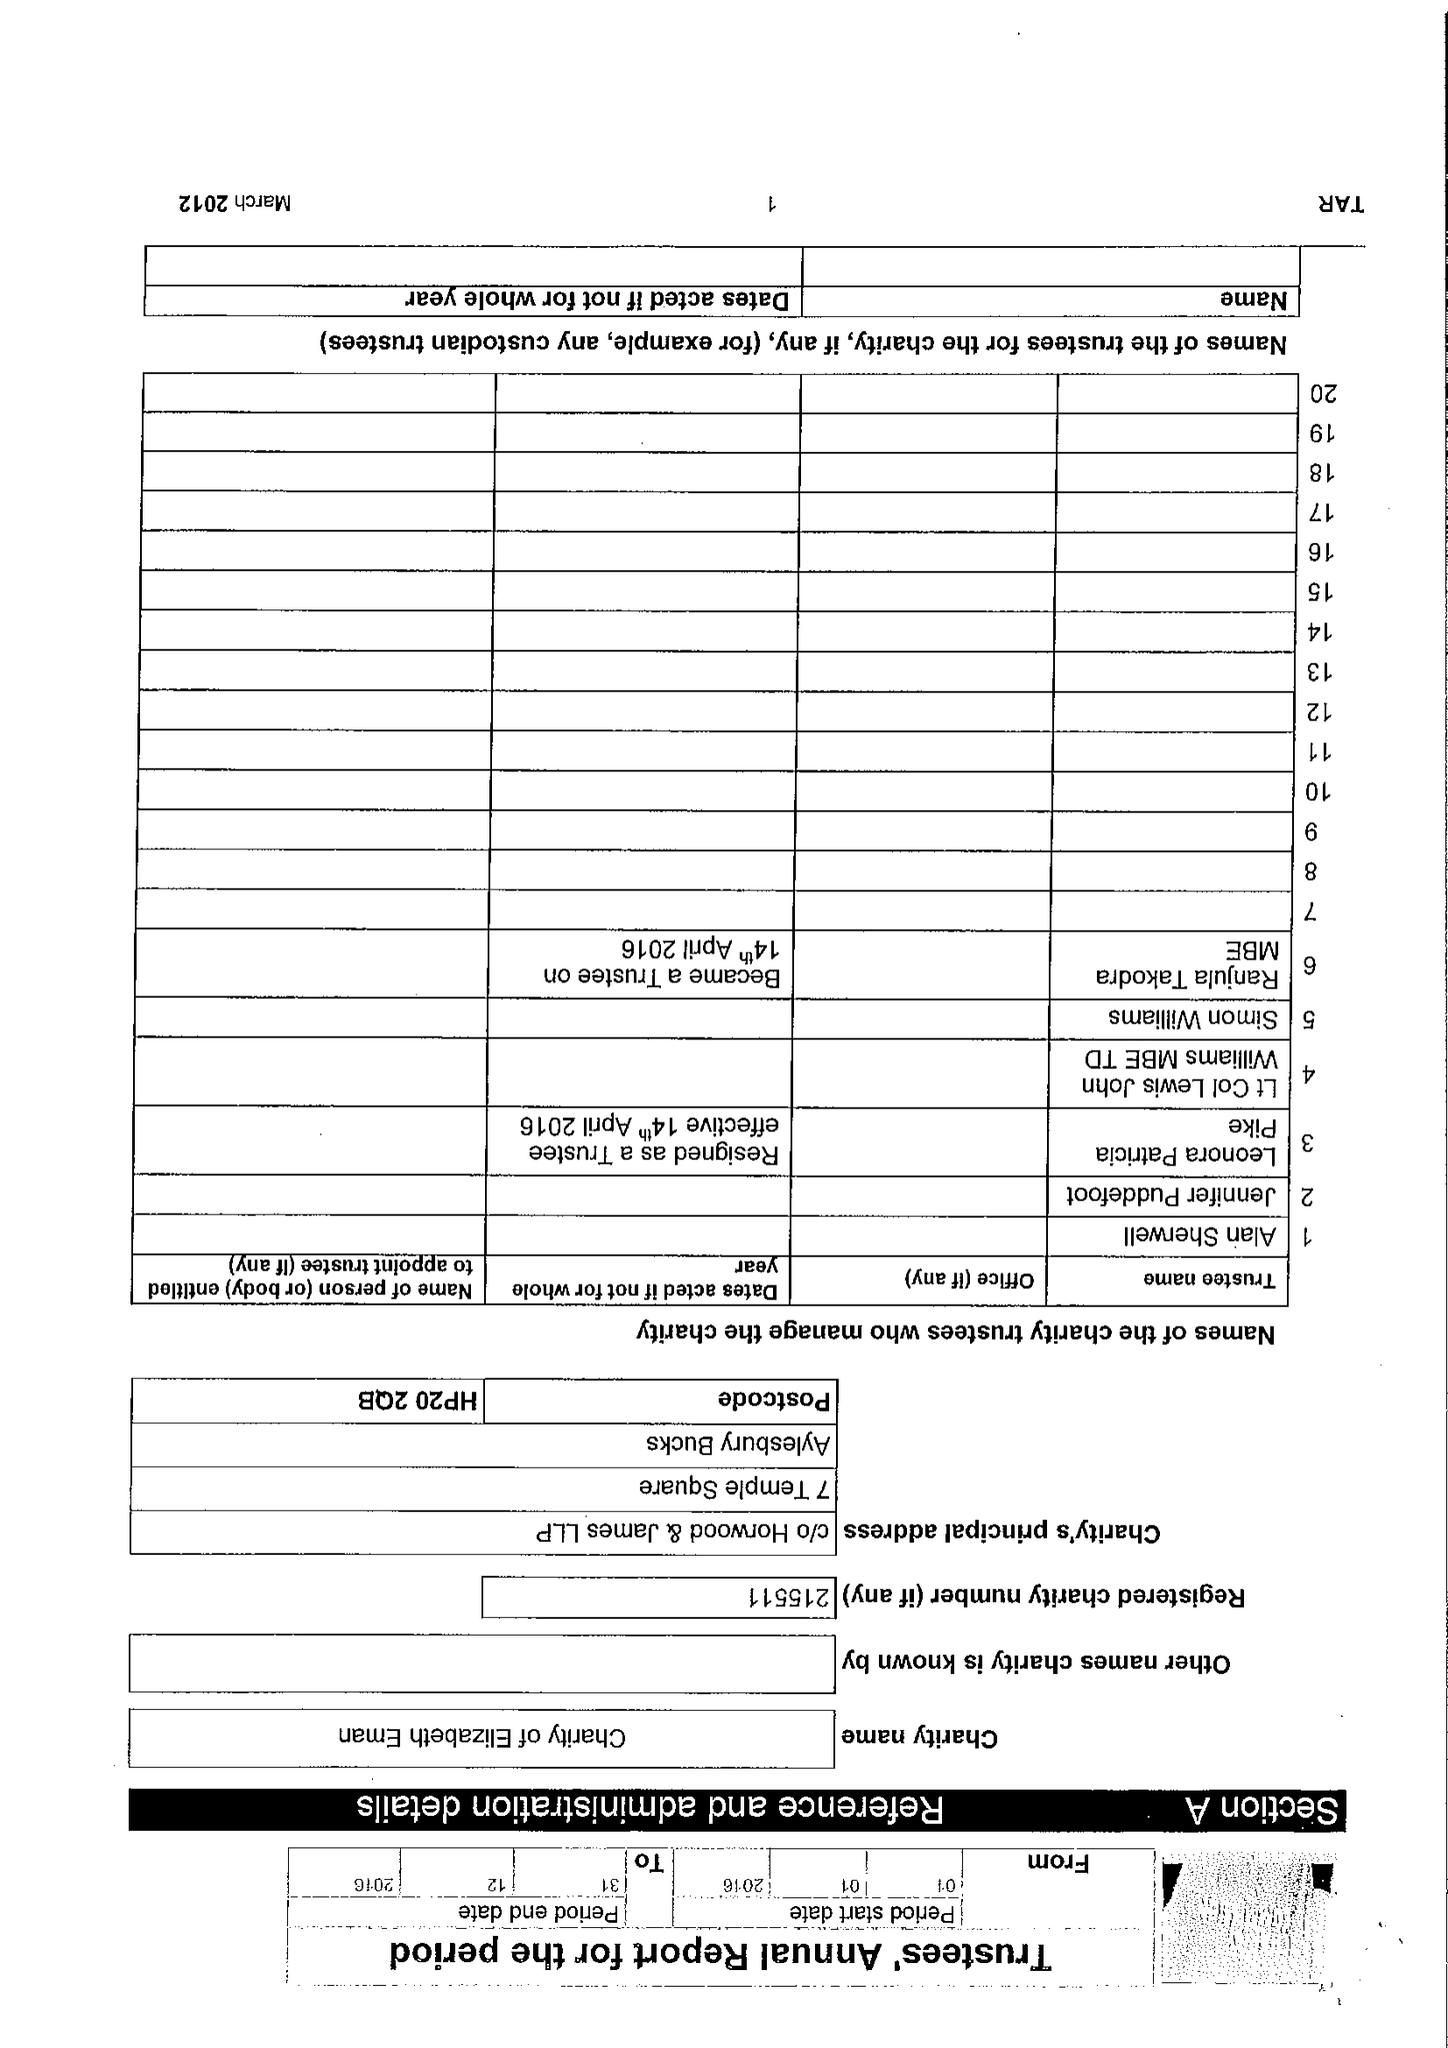What is the value for the charity_name?
Answer the question using a single word or phrase. Charity Of Elizabeth Eman 